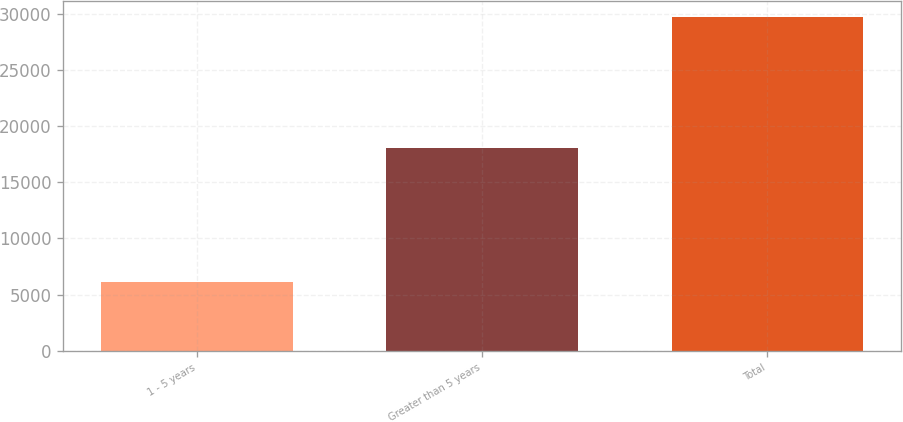<chart> <loc_0><loc_0><loc_500><loc_500><bar_chart><fcel>1 - 5 years<fcel>Greater than 5 years<fcel>Total<nl><fcel>6155<fcel>18092<fcel>29703<nl></chart> 